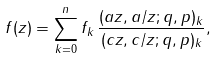Convert formula to latex. <formula><loc_0><loc_0><loc_500><loc_500>f ( z ) = \sum _ { k = 0 } ^ { n } f _ { k } \, \frac { ( a z , a / z ; q , p ) _ { k } } { ( c z , c / z ; q , p ) _ { k } } ,</formula> 